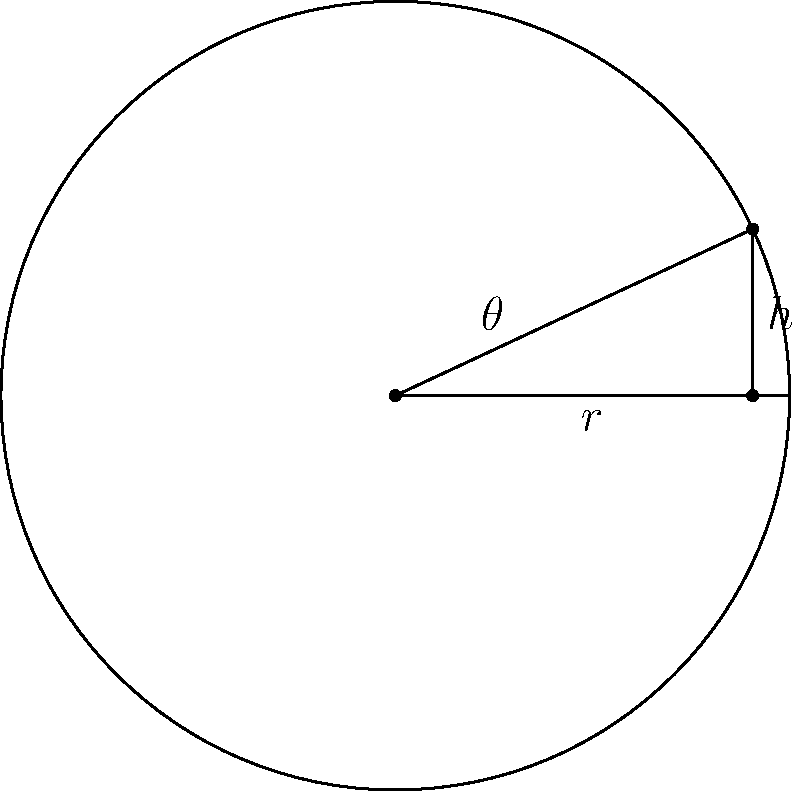As a NASCAR enthusiast, you're curious about the physics behind track design. At the Talladega Superspeedway, one of the turns has a banking angle of 25°. If the radius of the turn is 1000 feet, what is the height difference between the inside and outside edges of the track? Round your answer to the nearest foot. Let's approach this step-by-step:

1) In the diagram, we can see that the banking angle forms a right triangle with the radius of the turn and the height difference.

2) The banking angle ($\theta$) is given as 25°.

3) The radius ($r$) is 1000 feet.

4) We need to find the height ($h$).

5) This scenario involves the tangent trigonometric ratio. The tangent of an angle in a right triangle is the ratio of the opposite side to the adjacent side.

6) In this case:
   $\tan(\theta) = \frac{h}{r}$

7) Rearranging the equation:
   $h = r \tan(\theta)$

8) Plugging in the values:
   $h = 1000 \tan(25°)$

9) Using a calculator (or trigonometric tables):
   $h = 1000 \cdot 0.4663$

10) This gives us:
    $h = 466.3$ feet

11) Rounding to the nearest foot:
    $h \approx 466$ feet
Answer: 466 feet 